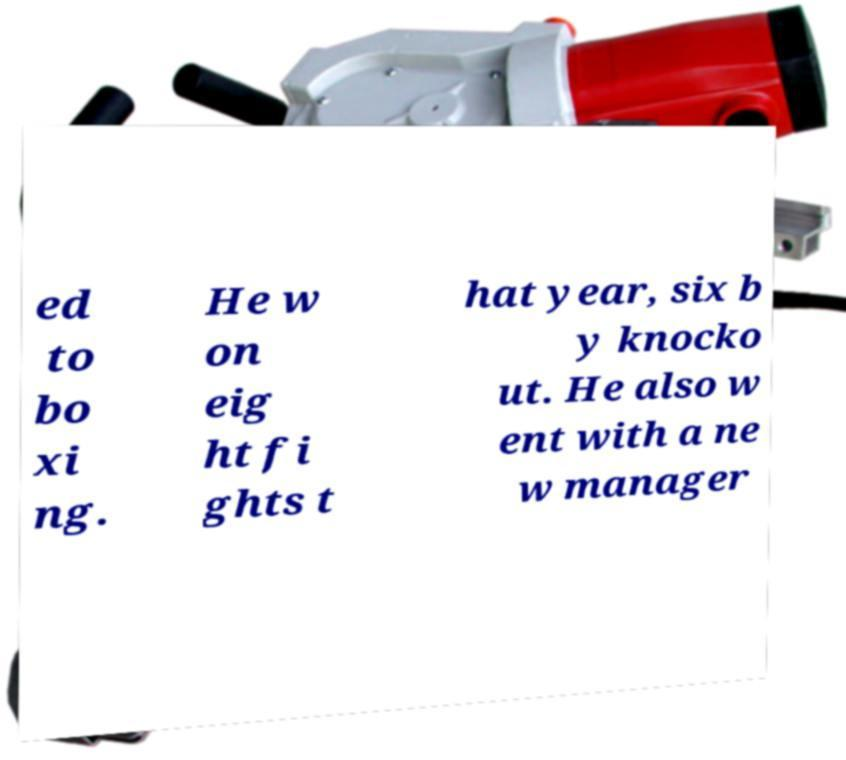What messages or text are displayed in this image? I need them in a readable, typed format. ed to bo xi ng. He w on eig ht fi ghts t hat year, six b y knocko ut. He also w ent with a ne w manager 